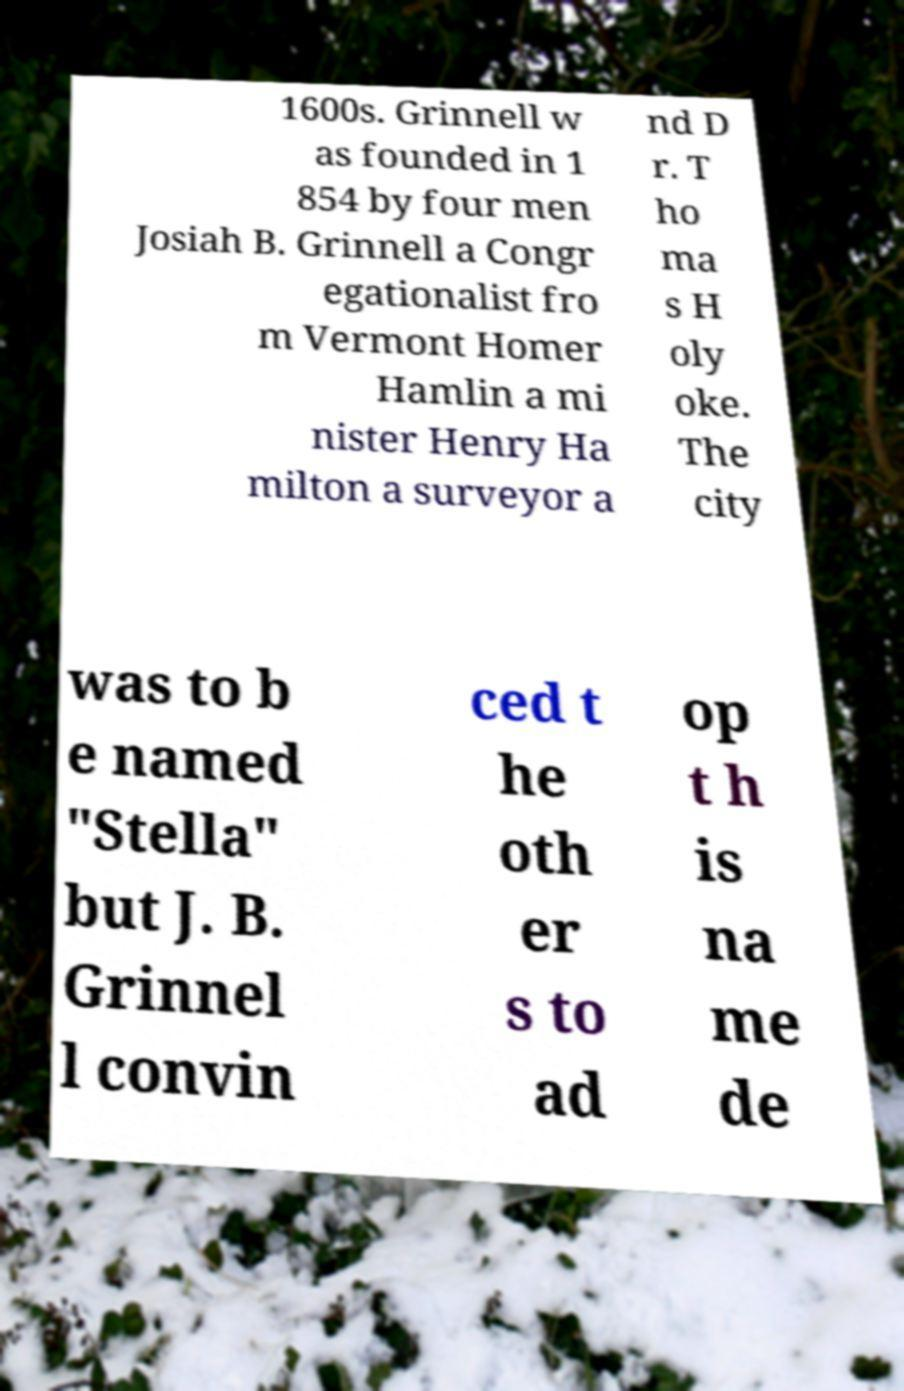Can you accurately transcribe the text from the provided image for me? 1600s. Grinnell w as founded in 1 854 by four men Josiah B. Grinnell a Congr egationalist fro m Vermont Homer Hamlin a mi nister Henry Ha milton a surveyor a nd D r. T ho ma s H oly oke. The city was to b e named "Stella" but J. B. Grinnel l convin ced t he oth er s to ad op t h is na me de 